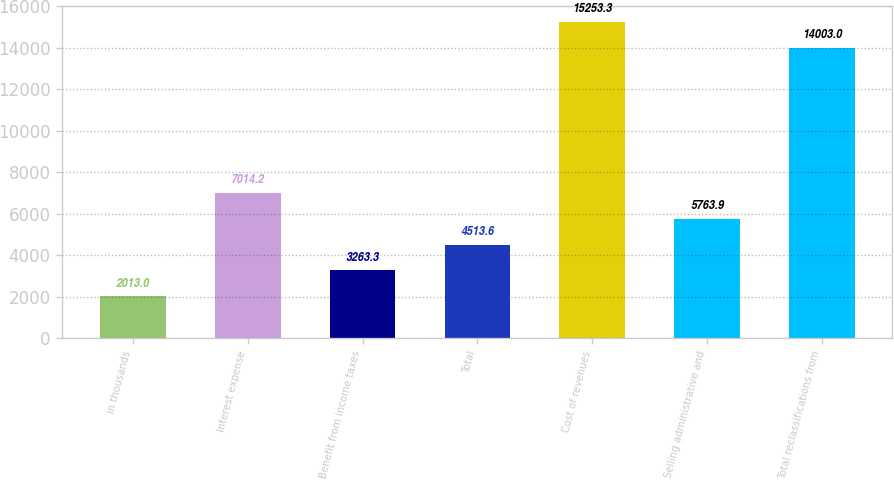Convert chart to OTSL. <chart><loc_0><loc_0><loc_500><loc_500><bar_chart><fcel>in thousands<fcel>Interest expense<fcel>Benefit from income taxes<fcel>Total<fcel>Cost of revenues<fcel>Selling administrative and<fcel>Total reclassifications from<nl><fcel>2013<fcel>7014.2<fcel>3263.3<fcel>4513.6<fcel>15253.3<fcel>5763.9<fcel>14003<nl></chart> 